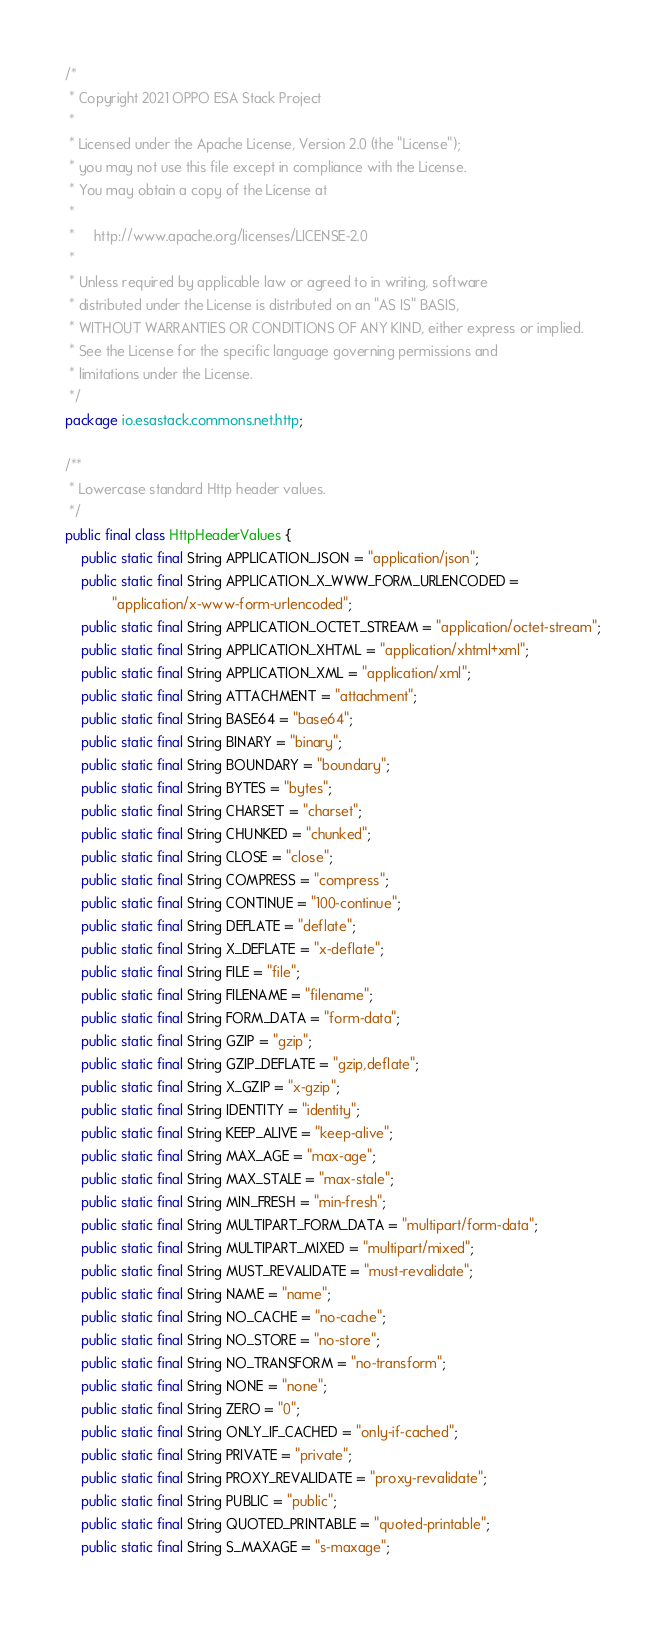Convert code to text. <code><loc_0><loc_0><loc_500><loc_500><_Java_>/*
 * Copyright 2021 OPPO ESA Stack Project
 *
 * Licensed under the Apache License, Version 2.0 (the "License");
 * you may not use this file except in compliance with the License.
 * You may obtain a copy of the License at
 *
 *     http://www.apache.org/licenses/LICENSE-2.0
 *
 * Unless required by applicable law or agreed to in writing, software
 * distributed under the License is distributed on an "AS IS" BASIS,
 * WITHOUT WARRANTIES OR CONDITIONS OF ANY KIND, either express or implied.
 * See the License for the specific language governing permissions and
 * limitations under the License.
 */
package io.esastack.commons.net.http;

/**
 * Lowercase standard Http header values.
 */
public final class HttpHeaderValues {
    public static final String APPLICATION_JSON = "application/json";
    public static final String APPLICATION_X_WWW_FORM_URLENCODED =
            "application/x-www-form-urlencoded";
    public static final String APPLICATION_OCTET_STREAM = "application/octet-stream";
    public static final String APPLICATION_XHTML = "application/xhtml+xml";
    public static final String APPLICATION_XML = "application/xml";
    public static final String ATTACHMENT = "attachment";
    public static final String BASE64 = "base64";
    public static final String BINARY = "binary";
    public static final String BOUNDARY = "boundary";
    public static final String BYTES = "bytes";
    public static final String CHARSET = "charset";
    public static final String CHUNKED = "chunked";
    public static final String CLOSE = "close";
    public static final String COMPRESS = "compress";
    public static final String CONTINUE = "100-continue";
    public static final String DEFLATE = "deflate";
    public static final String X_DEFLATE = "x-deflate";
    public static final String FILE = "file";
    public static final String FILENAME = "filename";
    public static final String FORM_DATA = "form-data";
    public static final String GZIP = "gzip";
    public static final String GZIP_DEFLATE = "gzip,deflate";
    public static final String X_GZIP = "x-gzip";
    public static final String IDENTITY = "identity";
    public static final String KEEP_ALIVE = "keep-alive";
    public static final String MAX_AGE = "max-age";
    public static final String MAX_STALE = "max-stale";
    public static final String MIN_FRESH = "min-fresh";
    public static final String MULTIPART_FORM_DATA = "multipart/form-data";
    public static final String MULTIPART_MIXED = "multipart/mixed";
    public static final String MUST_REVALIDATE = "must-revalidate";
    public static final String NAME = "name";
    public static final String NO_CACHE = "no-cache";
    public static final String NO_STORE = "no-store";
    public static final String NO_TRANSFORM = "no-transform";
    public static final String NONE = "none";
    public static final String ZERO = "0";
    public static final String ONLY_IF_CACHED = "only-if-cached";
    public static final String PRIVATE = "private";
    public static final String PROXY_REVALIDATE = "proxy-revalidate";
    public static final String PUBLIC = "public";
    public static final String QUOTED_PRINTABLE = "quoted-printable";
    public static final String S_MAXAGE = "s-maxage";</code> 